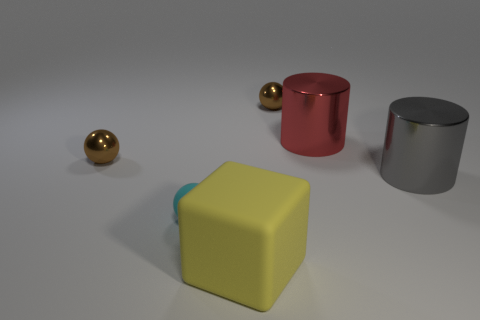Add 2 tiny objects. How many objects exist? 8 Subtract all small cyan rubber balls. How many balls are left? 2 Subtract 1 cylinders. How many cylinders are left? 1 Subtract all cyan spheres. How many spheres are left? 2 Subtract all cubes. How many objects are left? 5 Subtract all matte things. Subtract all small green metal cylinders. How many objects are left? 4 Add 5 small rubber spheres. How many small rubber spheres are left? 6 Add 1 yellow matte things. How many yellow matte things exist? 2 Subtract 0 blue spheres. How many objects are left? 6 Subtract all blue blocks. Subtract all blue spheres. How many blocks are left? 1 